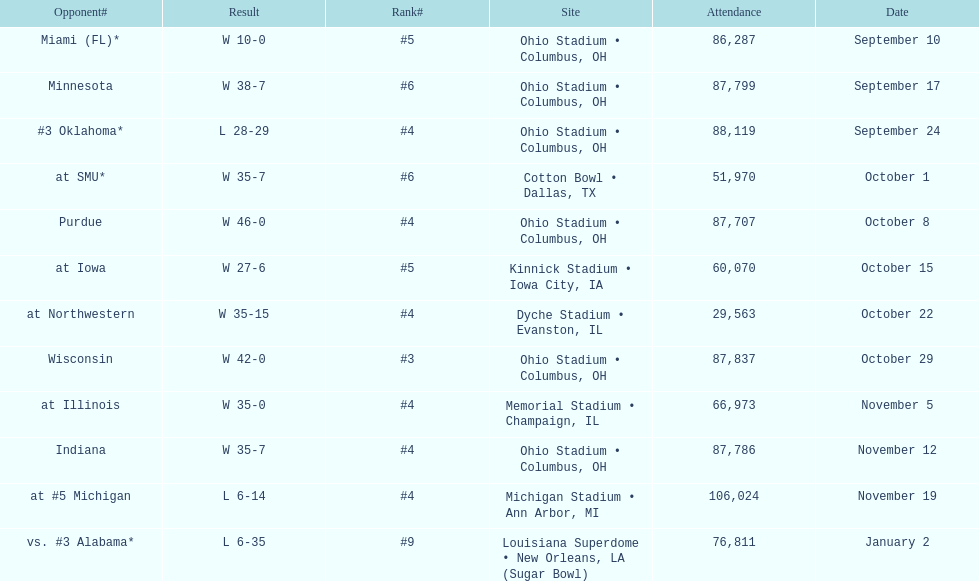Which date was attended by the most people? November 19. 